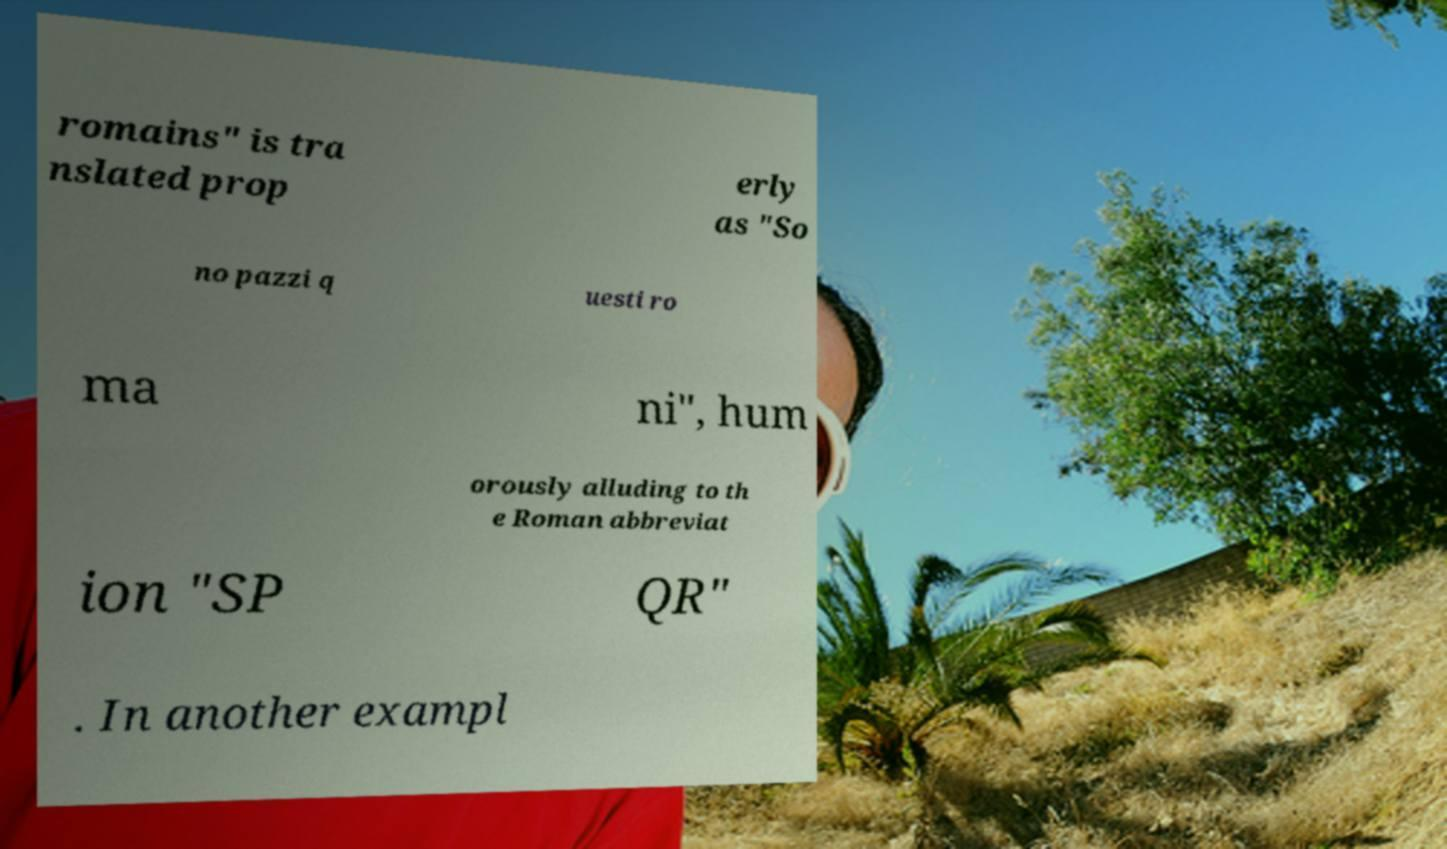There's text embedded in this image that I need extracted. Can you transcribe it verbatim? romains" is tra nslated prop erly as "So no pazzi q uesti ro ma ni", hum orously alluding to th e Roman abbreviat ion "SP QR" . In another exampl 